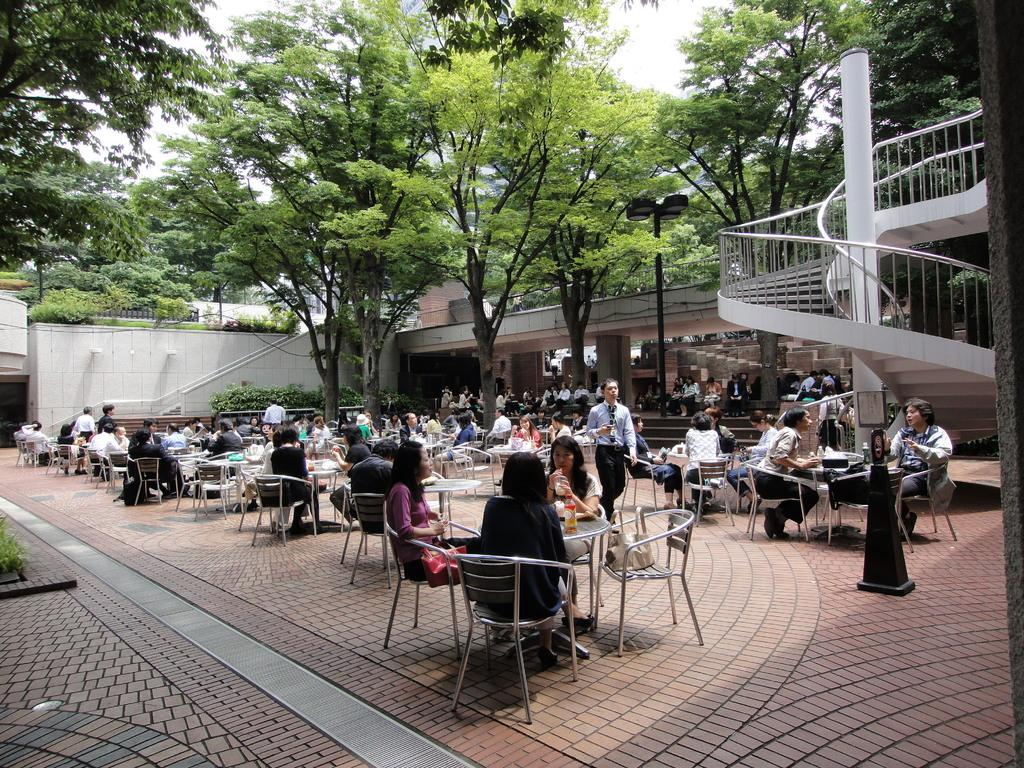What type of space is visible in the image? There is an open area in the image. What are the people in the open area doing? People are seated on chairs in the open area. Is there any movement happening in the open area? Yes, there is a person walking in the open area. What can be seen around the open area? There are trees around the open area. Are there any architectural features visible in the image? Yes, there are stairs visible in the image. What type of calculator is being used by the person walking in the image? There is no calculator present in the image; the person is simply walking in the open area. What force is being applied by the trees in the image? The trees in the image are not applying any force; they are stationary and not interacting with the people or the open area. 